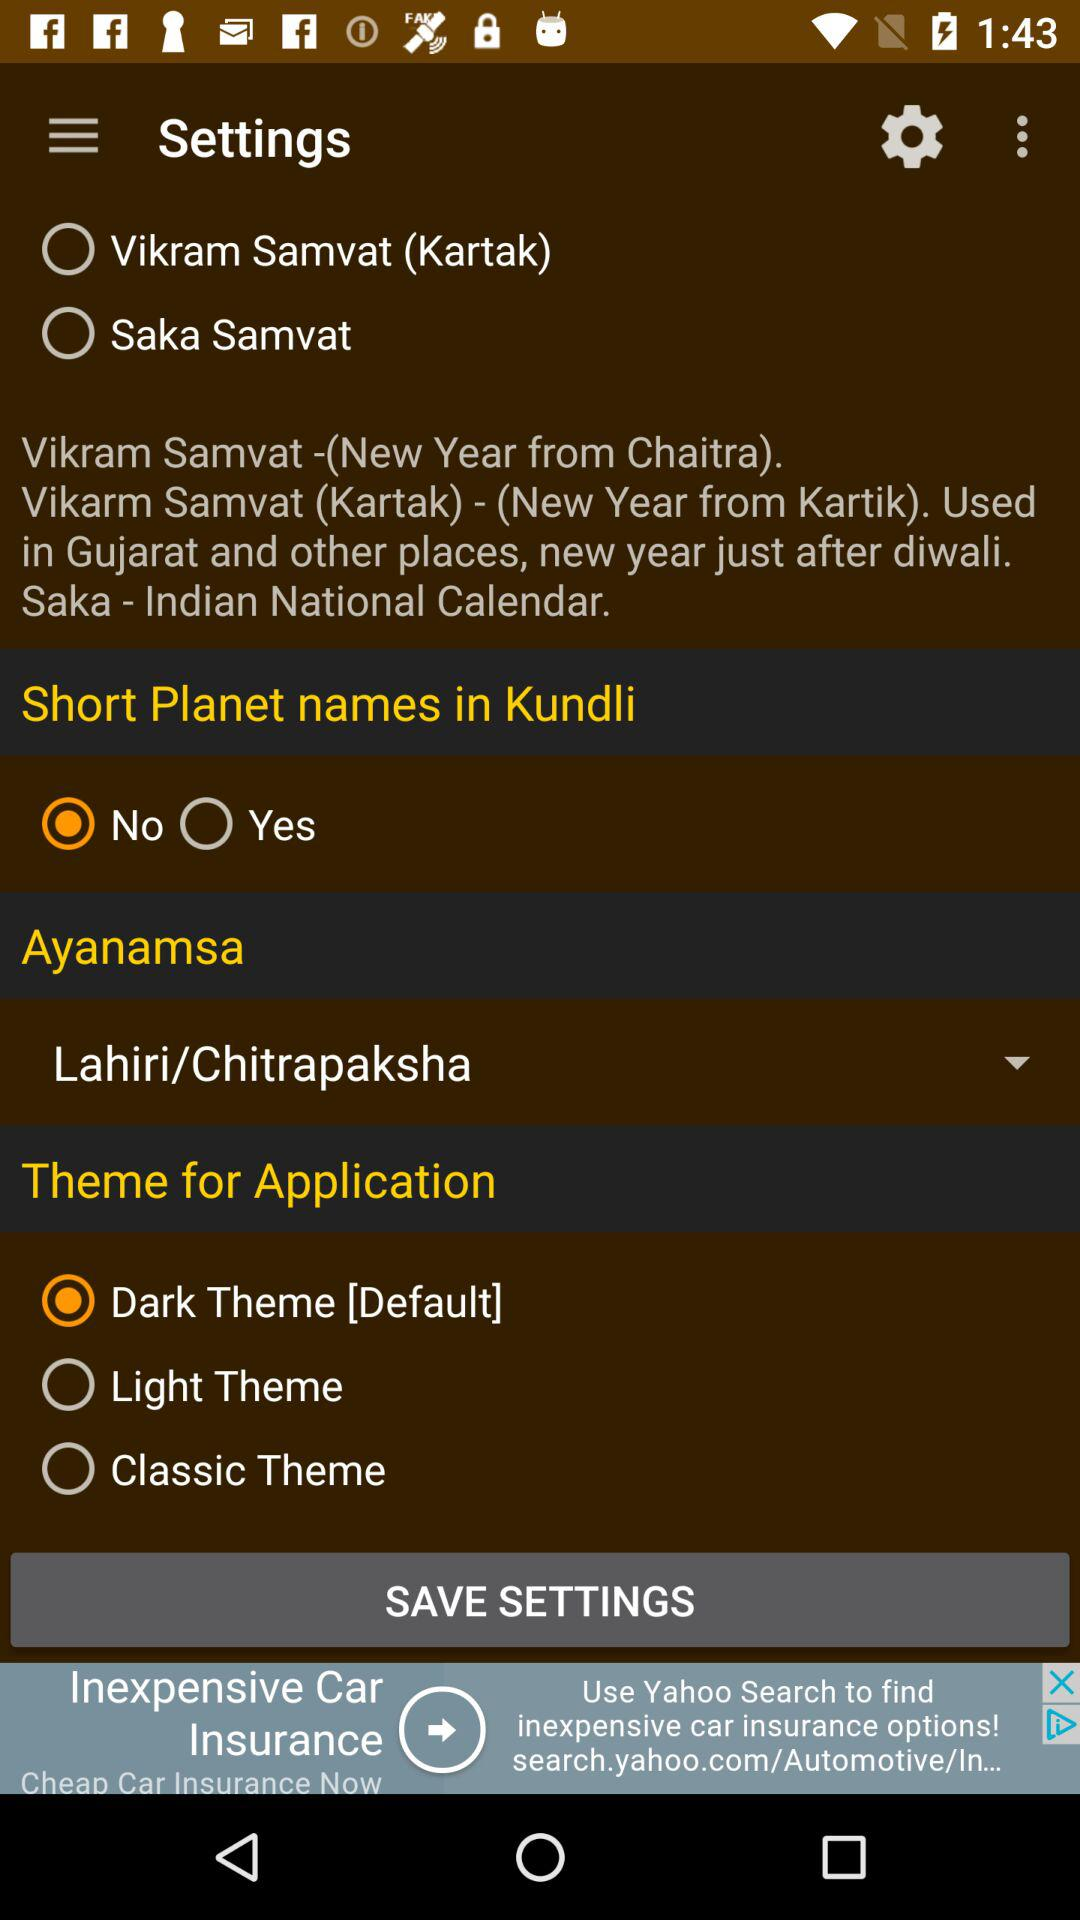What option is selected in "Short Planet names in Kundli"? The selected option is "No". 